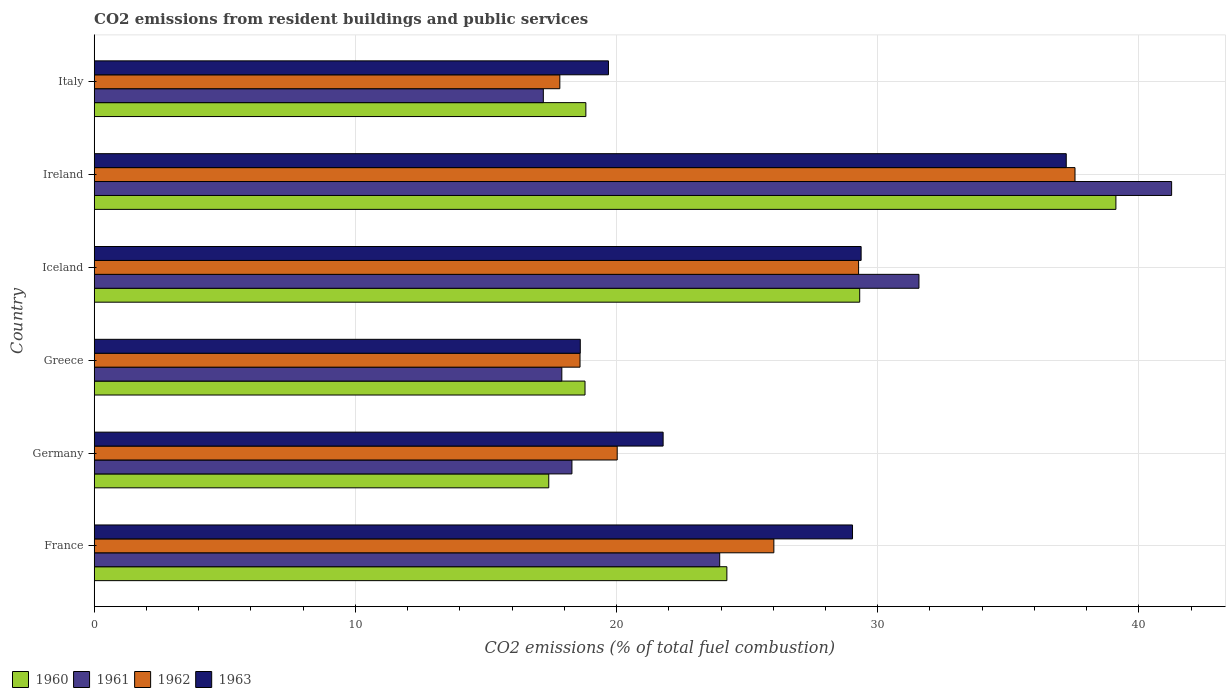Are the number of bars per tick equal to the number of legend labels?
Provide a succinct answer. Yes. How many bars are there on the 6th tick from the bottom?
Provide a short and direct response. 4. What is the label of the 4th group of bars from the top?
Ensure brevity in your answer.  Greece. What is the total CO2 emitted in 1961 in Greece?
Give a very brief answer. 17.9. Across all countries, what is the maximum total CO2 emitted in 1961?
Provide a succinct answer. 41.25. Across all countries, what is the minimum total CO2 emitted in 1960?
Your response must be concise. 17.4. In which country was the total CO2 emitted in 1963 maximum?
Keep it short and to the point. Ireland. What is the total total CO2 emitted in 1962 in the graph?
Give a very brief answer. 149.3. What is the difference between the total CO2 emitted in 1960 in Germany and that in Ireland?
Provide a short and direct response. -21.72. What is the difference between the total CO2 emitted in 1963 in Ireland and the total CO2 emitted in 1961 in France?
Make the answer very short. 13.27. What is the average total CO2 emitted in 1960 per country?
Offer a terse response. 24.61. What is the difference between the total CO2 emitted in 1963 and total CO2 emitted in 1962 in Italy?
Provide a short and direct response. 1.86. In how many countries, is the total CO2 emitted in 1960 greater than 32 ?
Your answer should be very brief. 1. What is the ratio of the total CO2 emitted in 1962 in Ireland to that in Italy?
Offer a very short reply. 2.11. Is the total CO2 emitted in 1963 in Ireland less than that in Italy?
Your response must be concise. No. Is the difference between the total CO2 emitted in 1963 in France and Iceland greater than the difference between the total CO2 emitted in 1962 in France and Iceland?
Give a very brief answer. Yes. What is the difference between the highest and the second highest total CO2 emitted in 1961?
Your answer should be compact. 9.67. What is the difference between the highest and the lowest total CO2 emitted in 1960?
Your response must be concise. 21.72. In how many countries, is the total CO2 emitted in 1961 greater than the average total CO2 emitted in 1961 taken over all countries?
Ensure brevity in your answer.  2. Is it the case that in every country, the sum of the total CO2 emitted in 1961 and total CO2 emitted in 1963 is greater than the sum of total CO2 emitted in 1962 and total CO2 emitted in 1960?
Keep it short and to the point. No. What does the 2nd bar from the top in Iceland represents?
Provide a short and direct response. 1962. Is it the case that in every country, the sum of the total CO2 emitted in 1961 and total CO2 emitted in 1963 is greater than the total CO2 emitted in 1960?
Your answer should be very brief. Yes. How many bars are there?
Give a very brief answer. 24. Are all the bars in the graph horizontal?
Keep it short and to the point. Yes. How many countries are there in the graph?
Give a very brief answer. 6. Does the graph contain any zero values?
Ensure brevity in your answer.  No. Where does the legend appear in the graph?
Give a very brief answer. Bottom left. What is the title of the graph?
Ensure brevity in your answer.  CO2 emissions from resident buildings and public services. What is the label or title of the X-axis?
Offer a very short reply. CO2 emissions (% of total fuel combustion). What is the label or title of the Y-axis?
Keep it short and to the point. Country. What is the CO2 emissions (% of total fuel combustion) in 1960 in France?
Make the answer very short. 24.22. What is the CO2 emissions (% of total fuel combustion) of 1961 in France?
Ensure brevity in your answer.  23.95. What is the CO2 emissions (% of total fuel combustion) in 1962 in France?
Make the answer very short. 26.02. What is the CO2 emissions (% of total fuel combustion) of 1963 in France?
Your answer should be very brief. 29.04. What is the CO2 emissions (% of total fuel combustion) in 1960 in Germany?
Ensure brevity in your answer.  17.4. What is the CO2 emissions (% of total fuel combustion) of 1961 in Germany?
Keep it short and to the point. 18.29. What is the CO2 emissions (% of total fuel combustion) of 1962 in Germany?
Ensure brevity in your answer.  20.03. What is the CO2 emissions (% of total fuel combustion) in 1963 in Germany?
Provide a short and direct response. 21.78. What is the CO2 emissions (% of total fuel combustion) of 1960 in Greece?
Keep it short and to the point. 18.79. What is the CO2 emissions (% of total fuel combustion) of 1961 in Greece?
Provide a short and direct response. 17.9. What is the CO2 emissions (% of total fuel combustion) in 1962 in Greece?
Ensure brevity in your answer.  18.6. What is the CO2 emissions (% of total fuel combustion) in 1963 in Greece?
Give a very brief answer. 18.61. What is the CO2 emissions (% of total fuel combustion) of 1960 in Iceland?
Your answer should be compact. 29.31. What is the CO2 emissions (% of total fuel combustion) in 1961 in Iceland?
Your answer should be very brief. 31.58. What is the CO2 emissions (% of total fuel combustion) in 1962 in Iceland?
Ensure brevity in your answer.  29.27. What is the CO2 emissions (% of total fuel combustion) in 1963 in Iceland?
Provide a short and direct response. 29.37. What is the CO2 emissions (% of total fuel combustion) of 1960 in Ireland?
Offer a very short reply. 39.12. What is the CO2 emissions (% of total fuel combustion) of 1961 in Ireland?
Offer a very short reply. 41.25. What is the CO2 emissions (% of total fuel combustion) of 1962 in Ireland?
Keep it short and to the point. 37.55. What is the CO2 emissions (% of total fuel combustion) in 1963 in Ireland?
Give a very brief answer. 37.22. What is the CO2 emissions (% of total fuel combustion) of 1960 in Italy?
Provide a succinct answer. 18.83. What is the CO2 emissions (% of total fuel combustion) in 1961 in Italy?
Offer a very short reply. 17.2. What is the CO2 emissions (% of total fuel combustion) of 1962 in Italy?
Provide a succinct answer. 17.83. What is the CO2 emissions (% of total fuel combustion) in 1963 in Italy?
Provide a succinct answer. 19.69. Across all countries, what is the maximum CO2 emissions (% of total fuel combustion) of 1960?
Provide a succinct answer. 39.12. Across all countries, what is the maximum CO2 emissions (% of total fuel combustion) in 1961?
Keep it short and to the point. 41.25. Across all countries, what is the maximum CO2 emissions (% of total fuel combustion) of 1962?
Offer a terse response. 37.55. Across all countries, what is the maximum CO2 emissions (% of total fuel combustion) of 1963?
Your answer should be compact. 37.22. Across all countries, what is the minimum CO2 emissions (% of total fuel combustion) in 1960?
Provide a succinct answer. 17.4. Across all countries, what is the minimum CO2 emissions (% of total fuel combustion) in 1961?
Give a very brief answer. 17.2. Across all countries, what is the minimum CO2 emissions (% of total fuel combustion) in 1962?
Make the answer very short. 17.83. Across all countries, what is the minimum CO2 emissions (% of total fuel combustion) in 1963?
Make the answer very short. 18.61. What is the total CO2 emissions (% of total fuel combustion) of 1960 in the graph?
Provide a short and direct response. 147.68. What is the total CO2 emissions (% of total fuel combustion) in 1961 in the graph?
Provide a short and direct response. 150.18. What is the total CO2 emissions (% of total fuel combustion) in 1962 in the graph?
Your answer should be compact. 149.3. What is the total CO2 emissions (% of total fuel combustion) in 1963 in the graph?
Your answer should be very brief. 155.71. What is the difference between the CO2 emissions (% of total fuel combustion) in 1960 in France and that in Germany?
Keep it short and to the point. 6.82. What is the difference between the CO2 emissions (% of total fuel combustion) of 1961 in France and that in Germany?
Your response must be concise. 5.66. What is the difference between the CO2 emissions (% of total fuel combustion) in 1962 in France and that in Germany?
Offer a terse response. 6. What is the difference between the CO2 emissions (% of total fuel combustion) of 1963 in France and that in Germany?
Provide a short and direct response. 7.25. What is the difference between the CO2 emissions (% of total fuel combustion) of 1960 in France and that in Greece?
Make the answer very short. 5.43. What is the difference between the CO2 emissions (% of total fuel combustion) of 1961 in France and that in Greece?
Your answer should be very brief. 6.05. What is the difference between the CO2 emissions (% of total fuel combustion) in 1962 in France and that in Greece?
Provide a succinct answer. 7.42. What is the difference between the CO2 emissions (% of total fuel combustion) in 1963 in France and that in Greece?
Provide a short and direct response. 10.42. What is the difference between the CO2 emissions (% of total fuel combustion) of 1960 in France and that in Iceland?
Offer a terse response. -5.09. What is the difference between the CO2 emissions (% of total fuel combustion) in 1961 in France and that in Iceland?
Give a very brief answer. -7.63. What is the difference between the CO2 emissions (% of total fuel combustion) in 1962 in France and that in Iceland?
Provide a succinct answer. -3.24. What is the difference between the CO2 emissions (% of total fuel combustion) of 1963 in France and that in Iceland?
Offer a terse response. -0.33. What is the difference between the CO2 emissions (% of total fuel combustion) in 1960 in France and that in Ireland?
Give a very brief answer. -14.9. What is the difference between the CO2 emissions (% of total fuel combustion) in 1961 in France and that in Ireland?
Offer a terse response. -17.3. What is the difference between the CO2 emissions (% of total fuel combustion) in 1962 in France and that in Ireland?
Your answer should be compact. -11.53. What is the difference between the CO2 emissions (% of total fuel combustion) of 1963 in France and that in Ireland?
Keep it short and to the point. -8.18. What is the difference between the CO2 emissions (% of total fuel combustion) in 1960 in France and that in Italy?
Provide a short and direct response. 5.4. What is the difference between the CO2 emissions (% of total fuel combustion) of 1961 in France and that in Italy?
Offer a terse response. 6.75. What is the difference between the CO2 emissions (% of total fuel combustion) of 1962 in France and that in Italy?
Offer a terse response. 8.19. What is the difference between the CO2 emissions (% of total fuel combustion) of 1963 in France and that in Italy?
Offer a very short reply. 9.34. What is the difference between the CO2 emissions (% of total fuel combustion) in 1960 in Germany and that in Greece?
Your answer should be very brief. -1.39. What is the difference between the CO2 emissions (% of total fuel combustion) of 1961 in Germany and that in Greece?
Ensure brevity in your answer.  0.39. What is the difference between the CO2 emissions (% of total fuel combustion) of 1962 in Germany and that in Greece?
Keep it short and to the point. 1.42. What is the difference between the CO2 emissions (% of total fuel combustion) in 1963 in Germany and that in Greece?
Your answer should be compact. 3.17. What is the difference between the CO2 emissions (% of total fuel combustion) in 1960 in Germany and that in Iceland?
Ensure brevity in your answer.  -11.91. What is the difference between the CO2 emissions (% of total fuel combustion) of 1961 in Germany and that in Iceland?
Make the answer very short. -13.29. What is the difference between the CO2 emissions (% of total fuel combustion) in 1962 in Germany and that in Iceland?
Make the answer very short. -9.24. What is the difference between the CO2 emissions (% of total fuel combustion) in 1963 in Germany and that in Iceland?
Offer a terse response. -7.58. What is the difference between the CO2 emissions (% of total fuel combustion) in 1960 in Germany and that in Ireland?
Your response must be concise. -21.72. What is the difference between the CO2 emissions (% of total fuel combustion) of 1961 in Germany and that in Ireland?
Your response must be concise. -22.96. What is the difference between the CO2 emissions (% of total fuel combustion) of 1962 in Germany and that in Ireland?
Make the answer very short. -17.53. What is the difference between the CO2 emissions (% of total fuel combustion) of 1963 in Germany and that in Ireland?
Ensure brevity in your answer.  -15.44. What is the difference between the CO2 emissions (% of total fuel combustion) in 1960 in Germany and that in Italy?
Offer a terse response. -1.42. What is the difference between the CO2 emissions (% of total fuel combustion) in 1961 in Germany and that in Italy?
Provide a succinct answer. 1.1. What is the difference between the CO2 emissions (% of total fuel combustion) of 1962 in Germany and that in Italy?
Give a very brief answer. 2.2. What is the difference between the CO2 emissions (% of total fuel combustion) of 1963 in Germany and that in Italy?
Ensure brevity in your answer.  2.09. What is the difference between the CO2 emissions (% of total fuel combustion) of 1960 in Greece and that in Iceland?
Your answer should be very brief. -10.52. What is the difference between the CO2 emissions (% of total fuel combustion) in 1961 in Greece and that in Iceland?
Make the answer very short. -13.67. What is the difference between the CO2 emissions (% of total fuel combustion) of 1962 in Greece and that in Iceland?
Give a very brief answer. -10.67. What is the difference between the CO2 emissions (% of total fuel combustion) of 1963 in Greece and that in Iceland?
Provide a short and direct response. -10.75. What is the difference between the CO2 emissions (% of total fuel combustion) of 1960 in Greece and that in Ireland?
Provide a short and direct response. -20.33. What is the difference between the CO2 emissions (% of total fuel combustion) of 1961 in Greece and that in Ireland?
Your answer should be compact. -23.35. What is the difference between the CO2 emissions (% of total fuel combustion) of 1962 in Greece and that in Ireland?
Provide a short and direct response. -18.95. What is the difference between the CO2 emissions (% of total fuel combustion) of 1963 in Greece and that in Ireland?
Make the answer very short. -18.61. What is the difference between the CO2 emissions (% of total fuel combustion) in 1960 in Greece and that in Italy?
Your answer should be compact. -0.03. What is the difference between the CO2 emissions (% of total fuel combustion) in 1961 in Greece and that in Italy?
Keep it short and to the point. 0.71. What is the difference between the CO2 emissions (% of total fuel combustion) in 1962 in Greece and that in Italy?
Ensure brevity in your answer.  0.77. What is the difference between the CO2 emissions (% of total fuel combustion) in 1963 in Greece and that in Italy?
Your answer should be compact. -1.08. What is the difference between the CO2 emissions (% of total fuel combustion) in 1960 in Iceland and that in Ireland?
Ensure brevity in your answer.  -9.81. What is the difference between the CO2 emissions (% of total fuel combustion) in 1961 in Iceland and that in Ireland?
Keep it short and to the point. -9.67. What is the difference between the CO2 emissions (% of total fuel combustion) in 1962 in Iceland and that in Ireland?
Provide a succinct answer. -8.29. What is the difference between the CO2 emissions (% of total fuel combustion) of 1963 in Iceland and that in Ireland?
Your answer should be very brief. -7.85. What is the difference between the CO2 emissions (% of total fuel combustion) of 1960 in Iceland and that in Italy?
Ensure brevity in your answer.  10.48. What is the difference between the CO2 emissions (% of total fuel combustion) in 1961 in Iceland and that in Italy?
Your response must be concise. 14.38. What is the difference between the CO2 emissions (% of total fuel combustion) of 1962 in Iceland and that in Italy?
Ensure brevity in your answer.  11.44. What is the difference between the CO2 emissions (% of total fuel combustion) of 1963 in Iceland and that in Italy?
Ensure brevity in your answer.  9.67. What is the difference between the CO2 emissions (% of total fuel combustion) in 1960 in Ireland and that in Italy?
Provide a short and direct response. 20.29. What is the difference between the CO2 emissions (% of total fuel combustion) of 1961 in Ireland and that in Italy?
Provide a succinct answer. 24.06. What is the difference between the CO2 emissions (% of total fuel combustion) of 1962 in Ireland and that in Italy?
Provide a short and direct response. 19.73. What is the difference between the CO2 emissions (% of total fuel combustion) of 1963 in Ireland and that in Italy?
Your answer should be compact. 17.53. What is the difference between the CO2 emissions (% of total fuel combustion) of 1960 in France and the CO2 emissions (% of total fuel combustion) of 1961 in Germany?
Make the answer very short. 5.93. What is the difference between the CO2 emissions (% of total fuel combustion) in 1960 in France and the CO2 emissions (% of total fuel combustion) in 1962 in Germany?
Ensure brevity in your answer.  4.2. What is the difference between the CO2 emissions (% of total fuel combustion) in 1960 in France and the CO2 emissions (% of total fuel combustion) in 1963 in Germany?
Give a very brief answer. 2.44. What is the difference between the CO2 emissions (% of total fuel combustion) of 1961 in France and the CO2 emissions (% of total fuel combustion) of 1962 in Germany?
Give a very brief answer. 3.92. What is the difference between the CO2 emissions (% of total fuel combustion) of 1961 in France and the CO2 emissions (% of total fuel combustion) of 1963 in Germany?
Your answer should be compact. 2.17. What is the difference between the CO2 emissions (% of total fuel combustion) of 1962 in France and the CO2 emissions (% of total fuel combustion) of 1963 in Germany?
Your answer should be compact. 4.24. What is the difference between the CO2 emissions (% of total fuel combustion) of 1960 in France and the CO2 emissions (% of total fuel combustion) of 1961 in Greece?
Offer a terse response. 6.32. What is the difference between the CO2 emissions (% of total fuel combustion) in 1960 in France and the CO2 emissions (% of total fuel combustion) in 1962 in Greece?
Offer a terse response. 5.62. What is the difference between the CO2 emissions (% of total fuel combustion) in 1960 in France and the CO2 emissions (% of total fuel combustion) in 1963 in Greece?
Give a very brief answer. 5.61. What is the difference between the CO2 emissions (% of total fuel combustion) of 1961 in France and the CO2 emissions (% of total fuel combustion) of 1962 in Greece?
Keep it short and to the point. 5.35. What is the difference between the CO2 emissions (% of total fuel combustion) in 1961 in France and the CO2 emissions (% of total fuel combustion) in 1963 in Greece?
Your response must be concise. 5.34. What is the difference between the CO2 emissions (% of total fuel combustion) in 1962 in France and the CO2 emissions (% of total fuel combustion) in 1963 in Greece?
Offer a terse response. 7.41. What is the difference between the CO2 emissions (% of total fuel combustion) of 1960 in France and the CO2 emissions (% of total fuel combustion) of 1961 in Iceland?
Keep it short and to the point. -7.35. What is the difference between the CO2 emissions (% of total fuel combustion) of 1960 in France and the CO2 emissions (% of total fuel combustion) of 1962 in Iceland?
Offer a very short reply. -5.04. What is the difference between the CO2 emissions (% of total fuel combustion) in 1960 in France and the CO2 emissions (% of total fuel combustion) in 1963 in Iceland?
Ensure brevity in your answer.  -5.14. What is the difference between the CO2 emissions (% of total fuel combustion) in 1961 in France and the CO2 emissions (% of total fuel combustion) in 1962 in Iceland?
Offer a terse response. -5.32. What is the difference between the CO2 emissions (% of total fuel combustion) in 1961 in France and the CO2 emissions (% of total fuel combustion) in 1963 in Iceland?
Your answer should be very brief. -5.41. What is the difference between the CO2 emissions (% of total fuel combustion) in 1962 in France and the CO2 emissions (% of total fuel combustion) in 1963 in Iceland?
Your response must be concise. -3.34. What is the difference between the CO2 emissions (% of total fuel combustion) of 1960 in France and the CO2 emissions (% of total fuel combustion) of 1961 in Ireland?
Provide a succinct answer. -17.03. What is the difference between the CO2 emissions (% of total fuel combustion) of 1960 in France and the CO2 emissions (% of total fuel combustion) of 1962 in Ireland?
Your answer should be compact. -13.33. What is the difference between the CO2 emissions (% of total fuel combustion) of 1960 in France and the CO2 emissions (% of total fuel combustion) of 1963 in Ireland?
Provide a short and direct response. -12.99. What is the difference between the CO2 emissions (% of total fuel combustion) in 1961 in France and the CO2 emissions (% of total fuel combustion) in 1962 in Ireland?
Provide a short and direct response. -13.6. What is the difference between the CO2 emissions (% of total fuel combustion) of 1961 in France and the CO2 emissions (% of total fuel combustion) of 1963 in Ireland?
Keep it short and to the point. -13.27. What is the difference between the CO2 emissions (% of total fuel combustion) of 1962 in France and the CO2 emissions (% of total fuel combustion) of 1963 in Ireland?
Make the answer very short. -11.2. What is the difference between the CO2 emissions (% of total fuel combustion) in 1960 in France and the CO2 emissions (% of total fuel combustion) in 1961 in Italy?
Give a very brief answer. 7.03. What is the difference between the CO2 emissions (% of total fuel combustion) in 1960 in France and the CO2 emissions (% of total fuel combustion) in 1962 in Italy?
Provide a succinct answer. 6.4. What is the difference between the CO2 emissions (% of total fuel combustion) in 1960 in France and the CO2 emissions (% of total fuel combustion) in 1963 in Italy?
Ensure brevity in your answer.  4.53. What is the difference between the CO2 emissions (% of total fuel combustion) in 1961 in France and the CO2 emissions (% of total fuel combustion) in 1962 in Italy?
Provide a short and direct response. 6.12. What is the difference between the CO2 emissions (% of total fuel combustion) of 1961 in France and the CO2 emissions (% of total fuel combustion) of 1963 in Italy?
Ensure brevity in your answer.  4.26. What is the difference between the CO2 emissions (% of total fuel combustion) in 1962 in France and the CO2 emissions (% of total fuel combustion) in 1963 in Italy?
Provide a short and direct response. 6.33. What is the difference between the CO2 emissions (% of total fuel combustion) of 1960 in Germany and the CO2 emissions (% of total fuel combustion) of 1961 in Greece?
Make the answer very short. -0.5. What is the difference between the CO2 emissions (% of total fuel combustion) of 1960 in Germany and the CO2 emissions (% of total fuel combustion) of 1962 in Greece?
Ensure brevity in your answer.  -1.2. What is the difference between the CO2 emissions (% of total fuel combustion) of 1960 in Germany and the CO2 emissions (% of total fuel combustion) of 1963 in Greece?
Offer a very short reply. -1.21. What is the difference between the CO2 emissions (% of total fuel combustion) in 1961 in Germany and the CO2 emissions (% of total fuel combustion) in 1962 in Greece?
Provide a short and direct response. -0.31. What is the difference between the CO2 emissions (% of total fuel combustion) of 1961 in Germany and the CO2 emissions (% of total fuel combustion) of 1963 in Greece?
Your answer should be compact. -0.32. What is the difference between the CO2 emissions (% of total fuel combustion) in 1962 in Germany and the CO2 emissions (% of total fuel combustion) in 1963 in Greece?
Your response must be concise. 1.41. What is the difference between the CO2 emissions (% of total fuel combustion) of 1960 in Germany and the CO2 emissions (% of total fuel combustion) of 1961 in Iceland?
Ensure brevity in your answer.  -14.17. What is the difference between the CO2 emissions (% of total fuel combustion) in 1960 in Germany and the CO2 emissions (% of total fuel combustion) in 1962 in Iceland?
Your answer should be compact. -11.86. What is the difference between the CO2 emissions (% of total fuel combustion) in 1960 in Germany and the CO2 emissions (% of total fuel combustion) in 1963 in Iceland?
Your answer should be compact. -11.96. What is the difference between the CO2 emissions (% of total fuel combustion) in 1961 in Germany and the CO2 emissions (% of total fuel combustion) in 1962 in Iceland?
Ensure brevity in your answer.  -10.98. What is the difference between the CO2 emissions (% of total fuel combustion) of 1961 in Germany and the CO2 emissions (% of total fuel combustion) of 1963 in Iceland?
Make the answer very short. -11.07. What is the difference between the CO2 emissions (% of total fuel combustion) in 1962 in Germany and the CO2 emissions (% of total fuel combustion) in 1963 in Iceland?
Ensure brevity in your answer.  -9.34. What is the difference between the CO2 emissions (% of total fuel combustion) in 1960 in Germany and the CO2 emissions (% of total fuel combustion) in 1961 in Ireland?
Offer a very short reply. -23.85. What is the difference between the CO2 emissions (% of total fuel combustion) in 1960 in Germany and the CO2 emissions (% of total fuel combustion) in 1962 in Ireland?
Give a very brief answer. -20.15. What is the difference between the CO2 emissions (% of total fuel combustion) in 1960 in Germany and the CO2 emissions (% of total fuel combustion) in 1963 in Ireland?
Ensure brevity in your answer.  -19.81. What is the difference between the CO2 emissions (% of total fuel combustion) in 1961 in Germany and the CO2 emissions (% of total fuel combustion) in 1962 in Ireland?
Your answer should be compact. -19.26. What is the difference between the CO2 emissions (% of total fuel combustion) of 1961 in Germany and the CO2 emissions (% of total fuel combustion) of 1963 in Ireland?
Offer a very short reply. -18.93. What is the difference between the CO2 emissions (% of total fuel combustion) of 1962 in Germany and the CO2 emissions (% of total fuel combustion) of 1963 in Ireland?
Ensure brevity in your answer.  -17.19. What is the difference between the CO2 emissions (% of total fuel combustion) of 1960 in Germany and the CO2 emissions (% of total fuel combustion) of 1961 in Italy?
Ensure brevity in your answer.  0.21. What is the difference between the CO2 emissions (% of total fuel combustion) in 1960 in Germany and the CO2 emissions (% of total fuel combustion) in 1962 in Italy?
Offer a very short reply. -0.42. What is the difference between the CO2 emissions (% of total fuel combustion) in 1960 in Germany and the CO2 emissions (% of total fuel combustion) in 1963 in Italy?
Provide a short and direct response. -2.29. What is the difference between the CO2 emissions (% of total fuel combustion) in 1961 in Germany and the CO2 emissions (% of total fuel combustion) in 1962 in Italy?
Provide a succinct answer. 0.46. What is the difference between the CO2 emissions (% of total fuel combustion) of 1961 in Germany and the CO2 emissions (% of total fuel combustion) of 1963 in Italy?
Offer a terse response. -1.4. What is the difference between the CO2 emissions (% of total fuel combustion) in 1962 in Germany and the CO2 emissions (% of total fuel combustion) in 1963 in Italy?
Your response must be concise. 0.33. What is the difference between the CO2 emissions (% of total fuel combustion) in 1960 in Greece and the CO2 emissions (% of total fuel combustion) in 1961 in Iceland?
Ensure brevity in your answer.  -12.79. What is the difference between the CO2 emissions (% of total fuel combustion) of 1960 in Greece and the CO2 emissions (% of total fuel combustion) of 1962 in Iceland?
Offer a very short reply. -10.48. What is the difference between the CO2 emissions (% of total fuel combustion) of 1960 in Greece and the CO2 emissions (% of total fuel combustion) of 1963 in Iceland?
Offer a terse response. -10.57. What is the difference between the CO2 emissions (% of total fuel combustion) of 1961 in Greece and the CO2 emissions (% of total fuel combustion) of 1962 in Iceland?
Your answer should be compact. -11.36. What is the difference between the CO2 emissions (% of total fuel combustion) of 1961 in Greece and the CO2 emissions (% of total fuel combustion) of 1963 in Iceland?
Provide a succinct answer. -11.46. What is the difference between the CO2 emissions (% of total fuel combustion) of 1962 in Greece and the CO2 emissions (% of total fuel combustion) of 1963 in Iceland?
Keep it short and to the point. -10.76. What is the difference between the CO2 emissions (% of total fuel combustion) in 1960 in Greece and the CO2 emissions (% of total fuel combustion) in 1961 in Ireland?
Your response must be concise. -22.46. What is the difference between the CO2 emissions (% of total fuel combustion) of 1960 in Greece and the CO2 emissions (% of total fuel combustion) of 1962 in Ireland?
Your response must be concise. -18.76. What is the difference between the CO2 emissions (% of total fuel combustion) of 1960 in Greece and the CO2 emissions (% of total fuel combustion) of 1963 in Ireland?
Your answer should be compact. -18.43. What is the difference between the CO2 emissions (% of total fuel combustion) of 1961 in Greece and the CO2 emissions (% of total fuel combustion) of 1962 in Ireland?
Your response must be concise. -19.65. What is the difference between the CO2 emissions (% of total fuel combustion) of 1961 in Greece and the CO2 emissions (% of total fuel combustion) of 1963 in Ireland?
Make the answer very short. -19.31. What is the difference between the CO2 emissions (% of total fuel combustion) of 1962 in Greece and the CO2 emissions (% of total fuel combustion) of 1963 in Ireland?
Offer a very short reply. -18.62. What is the difference between the CO2 emissions (% of total fuel combustion) in 1960 in Greece and the CO2 emissions (% of total fuel combustion) in 1961 in Italy?
Your response must be concise. 1.6. What is the difference between the CO2 emissions (% of total fuel combustion) in 1960 in Greece and the CO2 emissions (% of total fuel combustion) in 1962 in Italy?
Provide a short and direct response. 0.96. What is the difference between the CO2 emissions (% of total fuel combustion) in 1960 in Greece and the CO2 emissions (% of total fuel combustion) in 1963 in Italy?
Provide a short and direct response. -0.9. What is the difference between the CO2 emissions (% of total fuel combustion) of 1961 in Greece and the CO2 emissions (% of total fuel combustion) of 1962 in Italy?
Make the answer very short. 0.08. What is the difference between the CO2 emissions (% of total fuel combustion) of 1961 in Greece and the CO2 emissions (% of total fuel combustion) of 1963 in Italy?
Make the answer very short. -1.79. What is the difference between the CO2 emissions (% of total fuel combustion) in 1962 in Greece and the CO2 emissions (% of total fuel combustion) in 1963 in Italy?
Your answer should be very brief. -1.09. What is the difference between the CO2 emissions (% of total fuel combustion) of 1960 in Iceland and the CO2 emissions (% of total fuel combustion) of 1961 in Ireland?
Your response must be concise. -11.94. What is the difference between the CO2 emissions (% of total fuel combustion) in 1960 in Iceland and the CO2 emissions (% of total fuel combustion) in 1962 in Ireland?
Keep it short and to the point. -8.24. What is the difference between the CO2 emissions (% of total fuel combustion) in 1960 in Iceland and the CO2 emissions (% of total fuel combustion) in 1963 in Ireland?
Make the answer very short. -7.91. What is the difference between the CO2 emissions (% of total fuel combustion) of 1961 in Iceland and the CO2 emissions (% of total fuel combustion) of 1962 in Ireland?
Ensure brevity in your answer.  -5.98. What is the difference between the CO2 emissions (% of total fuel combustion) of 1961 in Iceland and the CO2 emissions (% of total fuel combustion) of 1963 in Ireland?
Give a very brief answer. -5.64. What is the difference between the CO2 emissions (% of total fuel combustion) of 1962 in Iceland and the CO2 emissions (% of total fuel combustion) of 1963 in Ireland?
Give a very brief answer. -7.95. What is the difference between the CO2 emissions (% of total fuel combustion) in 1960 in Iceland and the CO2 emissions (% of total fuel combustion) in 1961 in Italy?
Provide a short and direct response. 12.11. What is the difference between the CO2 emissions (% of total fuel combustion) of 1960 in Iceland and the CO2 emissions (% of total fuel combustion) of 1962 in Italy?
Give a very brief answer. 11.48. What is the difference between the CO2 emissions (% of total fuel combustion) in 1960 in Iceland and the CO2 emissions (% of total fuel combustion) in 1963 in Italy?
Keep it short and to the point. 9.62. What is the difference between the CO2 emissions (% of total fuel combustion) of 1961 in Iceland and the CO2 emissions (% of total fuel combustion) of 1962 in Italy?
Provide a short and direct response. 13.75. What is the difference between the CO2 emissions (% of total fuel combustion) in 1961 in Iceland and the CO2 emissions (% of total fuel combustion) in 1963 in Italy?
Make the answer very short. 11.89. What is the difference between the CO2 emissions (% of total fuel combustion) of 1962 in Iceland and the CO2 emissions (% of total fuel combustion) of 1963 in Italy?
Provide a succinct answer. 9.58. What is the difference between the CO2 emissions (% of total fuel combustion) of 1960 in Ireland and the CO2 emissions (% of total fuel combustion) of 1961 in Italy?
Make the answer very short. 21.92. What is the difference between the CO2 emissions (% of total fuel combustion) of 1960 in Ireland and the CO2 emissions (% of total fuel combustion) of 1962 in Italy?
Your response must be concise. 21.29. What is the difference between the CO2 emissions (% of total fuel combustion) of 1960 in Ireland and the CO2 emissions (% of total fuel combustion) of 1963 in Italy?
Give a very brief answer. 19.43. What is the difference between the CO2 emissions (% of total fuel combustion) in 1961 in Ireland and the CO2 emissions (% of total fuel combustion) in 1962 in Italy?
Your answer should be compact. 23.42. What is the difference between the CO2 emissions (% of total fuel combustion) of 1961 in Ireland and the CO2 emissions (% of total fuel combustion) of 1963 in Italy?
Give a very brief answer. 21.56. What is the difference between the CO2 emissions (% of total fuel combustion) in 1962 in Ireland and the CO2 emissions (% of total fuel combustion) in 1963 in Italy?
Keep it short and to the point. 17.86. What is the average CO2 emissions (% of total fuel combustion) of 1960 per country?
Offer a very short reply. 24.61. What is the average CO2 emissions (% of total fuel combustion) of 1961 per country?
Offer a very short reply. 25.03. What is the average CO2 emissions (% of total fuel combustion) of 1962 per country?
Your answer should be very brief. 24.88. What is the average CO2 emissions (% of total fuel combustion) in 1963 per country?
Keep it short and to the point. 25.95. What is the difference between the CO2 emissions (% of total fuel combustion) in 1960 and CO2 emissions (% of total fuel combustion) in 1961 in France?
Your response must be concise. 0.27. What is the difference between the CO2 emissions (% of total fuel combustion) of 1960 and CO2 emissions (% of total fuel combustion) of 1962 in France?
Offer a very short reply. -1.8. What is the difference between the CO2 emissions (% of total fuel combustion) of 1960 and CO2 emissions (% of total fuel combustion) of 1963 in France?
Your response must be concise. -4.81. What is the difference between the CO2 emissions (% of total fuel combustion) of 1961 and CO2 emissions (% of total fuel combustion) of 1962 in France?
Offer a terse response. -2.07. What is the difference between the CO2 emissions (% of total fuel combustion) in 1961 and CO2 emissions (% of total fuel combustion) in 1963 in France?
Make the answer very short. -5.08. What is the difference between the CO2 emissions (% of total fuel combustion) of 1962 and CO2 emissions (% of total fuel combustion) of 1963 in France?
Your response must be concise. -3.01. What is the difference between the CO2 emissions (% of total fuel combustion) in 1960 and CO2 emissions (% of total fuel combustion) in 1961 in Germany?
Ensure brevity in your answer.  -0.89. What is the difference between the CO2 emissions (% of total fuel combustion) of 1960 and CO2 emissions (% of total fuel combustion) of 1962 in Germany?
Give a very brief answer. -2.62. What is the difference between the CO2 emissions (% of total fuel combustion) in 1960 and CO2 emissions (% of total fuel combustion) in 1963 in Germany?
Your answer should be very brief. -4.38. What is the difference between the CO2 emissions (% of total fuel combustion) of 1961 and CO2 emissions (% of total fuel combustion) of 1962 in Germany?
Provide a short and direct response. -1.73. What is the difference between the CO2 emissions (% of total fuel combustion) of 1961 and CO2 emissions (% of total fuel combustion) of 1963 in Germany?
Provide a succinct answer. -3.49. What is the difference between the CO2 emissions (% of total fuel combustion) in 1962 and CO2 emissions (% of total fuel combustion) in 1963 in Germany?
Offer a terse response. -1.76. What is the difference between the CO2 emissions (% of total fuel combustion) in 1960 and CO2 emissions (% of total fuel combustion) in 1961 in Greece?
Make the answer very short. 0.89. What is the difference between the CO2 emissions (% of total fuel combustion) of 1960 and CO2 emissions (% of total fuel combustion) of 1962 in Greece?
Give a very brief answer. 0.19. What is the difference between the CO2 emissions (% of total fuel combustion) in 1960 and CO2 emissions (% of total fuel combustion) in 1963 in Greece?
Provide a short and direct response. 0.18. What is the difference between the CO2 emissions (% of total fuel combustion) of 1961 and CO2 emissions (% of total fuel combustion) of 1962 in Greece?
Your response must be concise. -0.7. What is the difference between the CO2 emissions (% of total fuel combustion) of 1961 and CO2 emissions (% of total fuel combustion) of 1963 in Greece?
Your answer should be very brief. -0.71. What is the difference between the CO2 emissions (% of total fuel combustion) of 1962 and CO2 emissions (% of total fuel combustion) of 1963 in Greece?
Your response must be concise. -0.01. What is the difference between the CO2 emissions (% of total fuel combustion) of 1960 and CO2 emissions (% of total fuel combustion) of 1961 in Iceland?
Give a very brief answer. -2.27. What is the difference between the CO2 emissions (% of total fuel combustion) in 1960 and CO2 emissions (% of total fuel combustion) in 1962 in Iceland?
Make the answer very short. 0.04. What is the difference between the CO2 emissions (% of total fuel combustion) of 1960 and CO2 emissions (% of total fuel combustion) of 1963 in Iceland?
Keep it short and to the point. -0.05. What is the difference between the CO2 emissions (% of total fuel combustion) in 1961 and CO2 emissions (% of total fuel combustion) in 1962 in Iceland?
Ensure brevity in your answer.  2.31. What is the difference between the CO2 emissions (% of total fuel combustion) in 1961 and CO2 emissions (% of total fuel combustion) in 1963 in Iceland?
Give a very brief answer. 2.21. What is the difference between the CO2 emissions (% of total fuel combustion) of 1962 and CO2 emissions (% of total fuel combustion) of 1963 in Iceland?
Your answer should be very brief. -0.1. What is the difference between the CO2 emissions (% of total fuel combustion) in 1960 and CO2 emissions (% of total fuel combustion) in 1961 in Ireland?
Make the answer very short. -2.13. What is the difference between the CO2 emissions (% of total fuel combustion) of 1960 and CO2 emissions (% of total fuel combustion) of 1962 in Ireland?
Provide a succinct answer. 1.57. What is the difference between the CO2 emissions (% of total fuel combustion) in 1960 and CO2 emissions (% of total fuel combustion) in 1963 in Ireland?
Give a very brief answer. 1.9. What is the difference between the CO2 emissions (% of total fuel combustion) of 1961 and CO2 emissions (% of total fuel combustion) of 1962 in Ireland?
Your answer should be very brief. 3.7. What is the difference between the CO2 emissions (% of total fuel combustion) of 1961 and CO2 emissions (% of total fuel combustion) of 1963 in Ireland?
Provide a short and direct response. 4.03. What is the difference between the CO2 emissions (% of total fuel combustion) of 1962 and CO2 emissions (% of total fuel combustion) of 1963 in Ireland?
Give a very brief answer. 0.34. What is the difference between the CO2 emissions (% of total fuel combustion) of 1960 and CO2 emissions (% of total fuel combustion) of 1961 in Italy?
Offer a very short reply. 1.63. What is the difference between the CO2 emissions (% of total fuel combustion) in 1960 and CO2 emissions (% of total fuel combustion) in 1963 in Italy?
Your response must be concise. -0.87. What is the difference between the CO2 emissions (% of total fuel combustion) of 1961 and CO2 emissions (% of total fuel combustion) of 1962 in Italy?
Offer a terse response. -0.63. What is the difference between the CO2 emissions (% of total fuel combustion) in 1961 and CO2 emissions (% of total fuel combustion) in 1963 in Italy?
Offer a very short reply. -2.49. What is the difference between the CO2 emissions (% of total fuel combustion) in 1962 and CO2 emissions (% of total fuel combustion) in 1963 in Italy?
Your answer should be very brief. -1.86. What is the ratio of the CO2 emissions (% of total fuel combustion) in 1960 in France to that in Germany?
Give a very brief answer. 1.39. What is the ratio of the CO2 emissions (% of total fuel combustion) in 1961 in France to that in Germany?
Provide a short and direct response. 1.31. What is the ratio of the CO2 emissions (% of total fuel combustion) of 1962 in France to that in Germany?
Provide a succinct answer. 1.3. What is the ratio of the CO2 emissions (% of total fuel combustion) of 1963 in France to that in Germany?
Offer a terse response. 1.33. What is the ratio of the CO2 emissions (% of total fuel combustion) of 1960 in France to that in Greece?
Offer a very short reply. 1.29. What is the ratio of the CO2 emissions (% of total fuel combustion) of 1961 in France to that in Greece?
Give a very brief answer. 1.34. What is the ratio of the CO2 emissions (% of total fuel combustion) in 1962 in France to that in Greece?
Your answer should be very brief. 1.4. What is the ratio of the CO2 emissions (% of total fuel combustion) in 1963 in France to that in Greece?
Offer a terse response. 1.56. What is the ratio of the CO2 emissions (% of total fuel combustion) of 1960 in France to that in Iceland?
Your response must be concise. 0.83. What is the ratio of the CO2 emissions (% of total fuel combustion) of 1961 in France to that in Iceland?
Ensure brevity in your answer.  0.76. What is the ratio of the CO2 emissions (% of total fuel combustion) in 1962 in France to that in Iceland?
Provide a succinct answer. 0.89. What is the ratio of the CO2 emissions (% of total fuel combustion) of 1963 in France to that in Iceland?
Offer a very short reply. 0.99. What is the ratio of the CO2 emissions (% of total fuel combustion) in 1960 in France to that in Ireland?
Your answer should be compact. 0.62. What is the ratio of the CO2 emissions (% of total fuel combustion) in 1961 in France to that in Ireland?
Your response must be concise. 0.58. What is the ratio of the CO2 emissions (% of total fuel combustion) of 1962 in France to that in Ireland?
Your answer should be compact. 0.69. What is the ratio of the CO2 emissions (% of total fuel combustion) of 1963 in France to that in Ireland?
Your response must be concise. 0.78. What is the ratio of the CO2 emissions (% of total fuel combustion) in 1960 in France to that in Italy?
Ensure brevity in your answer.  1.29. What is the ratio of the CO2 emissions (% of total fuel combustion) in 1961 in France to that in Italy?
Provide a short and direct response. 1.39. What is the ratio of the CO2 emissions (% of total fuel combustion) in 1962 in France to that in Italy?
Your answer should be compact. 1.46. What is the ratio of the CO2 emissions (% of total fuel combustion) of 1963 in France to that in Italy?
Provide a short and direct response. 1.47. What is the ratio of the CO2 emissions (% of total fuel combustion) of 1960 in Germany to that in Greece?
Offer a terse response. 0.93. What is the ratio of the CO2 emissions (% of total fuel combustion) in 1961 in Germany to that in Greece?
Keep it short and to the point. 1.02. What is the ratio of the CO2 emissions (% of total fuel combustion) in 1962 in Germany to that in Greece?
Make the answer very short. 1.08. What is the ratio of the CO2 emissions (% of total fuel combustion) of 1963 in Germany to that in Greece?
Ensure brevity in your answer.  1.17. What is the ratio of the CO2 emissions (% of total fuel combustion) in 1960 in Germany to that in Iceland?
Your answer should be compact. 0.59. What is the ratio of the CO2 emissions (% of total fuel combustion) in 1961 in Germany to that in Iceland?
Provide a succinct answer. 0.58. What is the ratio of the CO2 emissions (% of total fuel combustion) in 1962 in Germany to that in Iceland?
Give a very brief answer. 0.68. What is the ratio of the CO2 emissions (% of total fuel combustion) of 1963 in Germany to that in Iceland?
Ensure brevity in your answer.  0.74. What is the ratio of the CO2 emissions (% of total fuel combustion) in 1960 in Germany to that in Ireland?
Your response must be concise. 0.44. What is the ratio of the CO2 emissions (% of total fuel combustion) of 1961 in Germany to that in Ireland?
Your response must be concise. 0.44. What is the ratio of the CO2 emissions (% of total fuel combustion) in 1962 in Germany to that in Ireland?
Give a very brief answer. 0.53. What is the ratio of the CO2 emissions (% of total fuel combustion) of 1963 in Germany to that in Ireland?
Ensure brevity in your answer.  0.59. What is the ratio of the CO2 emissions (% of total fuel combustion) in 1960 in Germany to that in Italy?
Your answer should be compact. 0.92. What is the ratio of the CO2 emissions (% of total fuel combustion) of 1961 in Germany to that in Italy?
Keep it short and to the point. 1.06. What is the ratio of the CO2 emissions (% of total fuel combustion) of 1962 in Germany to that in Italy?
Your answer should be compact. 1.12. What is the ratio of the CO2 emissions (% of total fuel combustion) in 1963 in Germany to that in Italy?
Your answer should be compact. 1.11. What is the ratio of the CO2 emissions (% of total fuel combustion) of 1960 in Greece to that in Iceland?
Offer a terse response. 0.64. What is the ratio of the CO2 emissions (% of total fuel combustion) in 1961 in Greece to that in Iceland?
Make the answer very short. 0.57. What is the ratio of the CO2 emissions (% of total fuel combustion) in 1962 in Greece to that in Iceland?
Offer a very short reply. 0.64. What is the ratio of the CO2 emissions (% of total fuel combustion) of 1963 in Greece to that in Iceland?
Provide a short and direct response. 0.63. What is the ratio of the CO2 emissions (% of total fuel combustion) of 1960 in Greece to that in Ireland?
Your response must be concise. 0.48. What is the ratio of the CO2 emissions (% of total fuel combustion) in 1961 in Greece to that in Ireland?
Your answer should be very brief. 0.43. What is the ratio of the CO2 emissions (% of total fuel combustion) in 1962 in Greece to that in Ireland?
Keep it short and to the point. 0.5. What is the ratio of the CO2 emissions (% of total fuel combustion) of 1963 in Greece to that in Ireland?
Provide a succinct answer. 0.5. What is the ratio of the CO2 emissions (% of total fuel combustion) of 1961 in Greece to that in Italy?
Ensure brevity in your answer.  1.04. What is the ratio of the CO2 emissions (% of total fuel combustion) in 1962 in Greece to that in Italy?
Offer a very short reply. 1.04. What is the ratio of the CO2 emissions (% of total fuel combustion) in 1963 in Greece to that in Italy?
Ensure brevity in your answer.  0.95. What is the ratio of the CO2 emissions (% of total fuel combustion) of 1960 in Iceland to that in Ireland?
Offer a very short reply. 0.75. What is the ratio of the CO2 emissions (% of total fuel combustion) in 1961 in Iceland to that in Ireland?
Provide a short and direct response. 0.77. What is the ratio of the CO2 emissions (% of total fuel combustion) in 1962 in Iceland to that in Ireland?
Your answer should be compact. 0.78. What is the ratio of the CO2 emissions (% of total fuel combustion) of 1963 in Iceland to that in Ireland?
Your answer should be compact. 0.79. What is the ratio of the CO2 emissions (% of total fuel combustion) of 1960 in Iceland to that in Italy?
Offer a very short reply. 1.56. What is the ratio of the CO2 emissions (% of total fuel combustion) of 1961 in Iceland to that in Italy?
Give a very brief answer. 1.84. What is the ratio of the CO2 emissions (% of total fuel combustion) in 1962 in Iceland to that in Italy?
Your response must be concise. 1.64. What is the ratio of the CO2 emissions (% of total fuel combustion) in 1963 in Iceland to that in Italy?
Give a very brief answer. 1.49. What is the ratio of the CO2 emissions (% of total fuel combustion) in 1960 in Ireland to that in Italy?
Provide a short and direct response. 2.08. What is the ratio of the CO2 emissions (% of total fuel combustion) of 1961 in Ireland to that in Italy?
Make the answer very short. 2.4. What is the ratio of the CO2 emissions (% of total fuel combustion) of 1962 in Ireland to that in Italy?
Your answer should be compact. 2.11. What is the ratio of the CO2 emissions (% of total fuel combustion) in 1963 in Ireland to that in Italy?
Your answer should be compact. 1.89. What is the difference between the highest and the second highest CO2 emissions (% of total fuel combustion) in 1960?
Offer a terse response. 9.81. What is the difference between the highest and the second highest CO2 emissions (% of total fuel combustion) in 1961?
Give a very brief answer. 9.67. What is the difference between the highest and the second highest CO2 emissions (% of total fuel combustion) in 1962?
Your answer should be very brief. 8.29. What is the difference between the highest and the second highest CO2 emissions (% of total fuel combustion) of 1963?
Give a very brief answer. 7.85. What is the difference between the highest and the lowest CO2 emissions (% of total fuel combustion) of 1960?
Provide a succinct answer. 21.72. What is the difference between the highest and the lowest CO2 emissions (% of total fuel combustion) of 1961?
Provide a short and direct response. 24.06. What is the difference between the highest and the lowest CO2 emissions (% of total fuel combustion) in 1962?
Ensure brevity in your answer.  19.73. What is the difference between the highest and the lowest CO2 emissions (% of total fuel combustion) of 1963?
Your answer should be very brief. 18.61. 